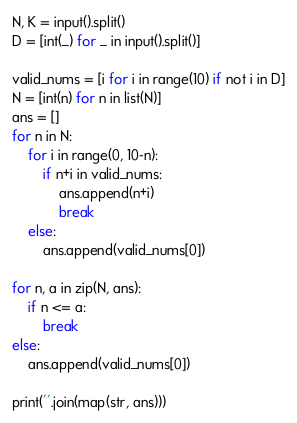<code> <loc_0><loc_0><loc_500><loc_500><_Python_>N, K = input().split()
D = [int(_) for _ in input().split()]

valid_nums = [i for i in range(10) if not i in D]
N = [int(n) for n in list(N)]
ans = []
for n in N:
    for i in range(0, 10-n):
        if n+i in valid_nums:
            ans.append(n+i)
            break
    else:
        ans.append(valid_nums[0])

for n, a in zip(N, ans):
    if n <= a:
        break
else:
    ans.append(valid_nums[0])

print(''.join(map(str, ans)))
</code> 